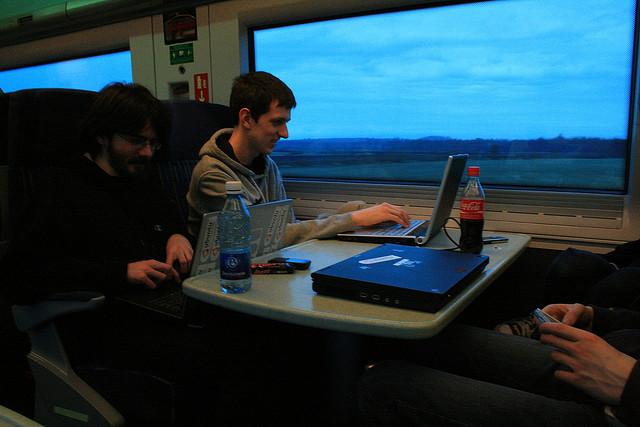Is the boy's hand in the proper position for optimal typing?
Concise answer only. No. What kind of haircut does the boy have?
Keep it brief. Short. Sunny or overcast?
Short answer required. Overcast. Is it tea time?
Concise answer only. No. What are these people riding in?
Quick response, please. Train. How many laptops are there?
Give a very brief answer. 3. Is anyone drinking soda?
Short answer required. Yes. 